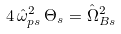Convert formula to latex. <formula><loc_0><loc_0><loc_500><loc_500>4 \, \hat { \omega } _ { p s } ^ { 2 } \, \Theta _ { s } = \hat { \Omega } _ { B s } ^ { 2 }</formula> 